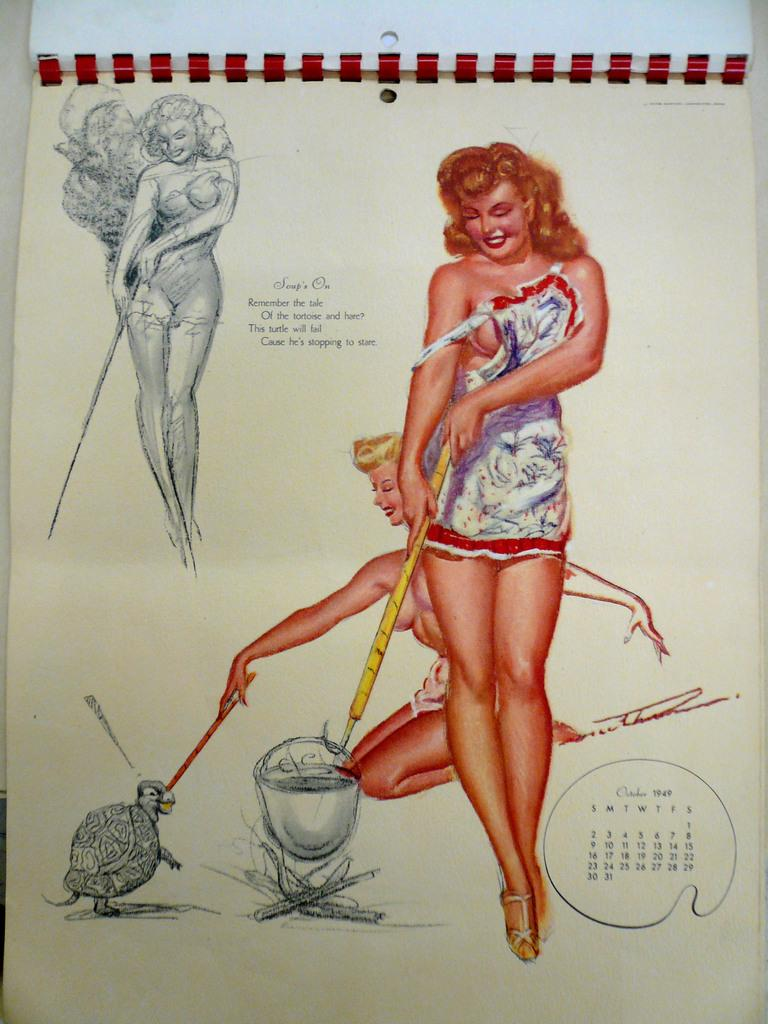What is depicted in the image? There is a drawing of people in the image. What are the people in the drawing wearing? The people in the drawing are wearing clothes. What type of artwork is present in the image? The image contains a sketch. Are there any words or letters in the image? Yes, there is text present in the image. What type of guide is the person holding in the image? There is no person holding a guide in the image; it contains a drawing of people wearing clothes and a sketch with text. What type of trousers are the people wearing in the image? The provided facts do not specify the type of trousers worn by the people in the drawing. 